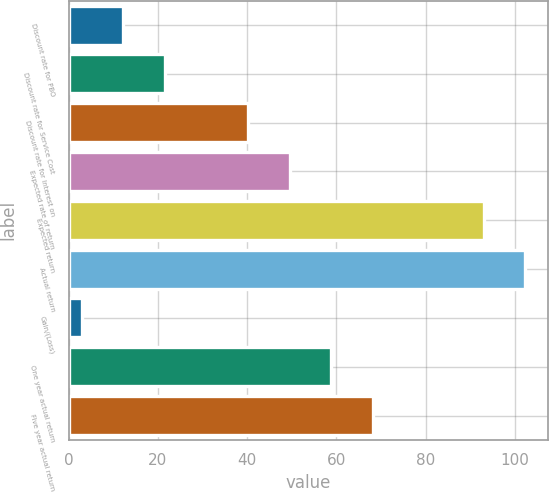Convert chart to OTSL. <chart><loc_0><loc_0><loc_500><loc_500><bar_chart><fcel>Discount rate for PBO<fcel>Discount rate for Service Cost<fcel>Discount rate for Interest on<fcel>Expected rate of return<fcel>Expected return<fcel>Actual return<fcel>Gain/(Loss)<fcel>One year actual return<fcel>Five year actual return<nl><fcel>12.3<fcel>21.6<fcel>40.2<fcel>49.5<fcel>93<fcel>102.3<fcel>3<fcel>58.8<fcel>68.1<nl></chart> 